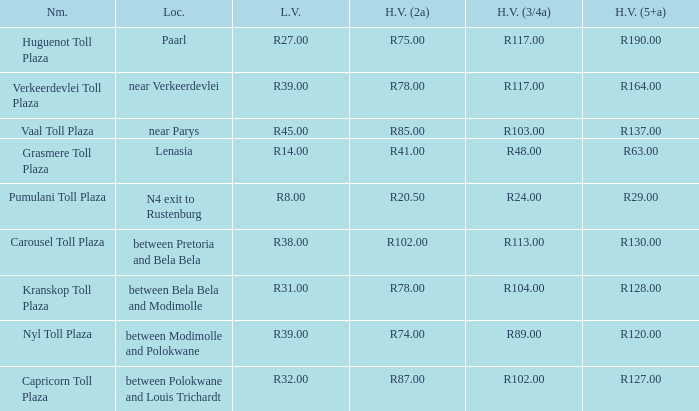How much do light vehicles pay at the toll booth located between bela bela and modimolle? R31.00. 